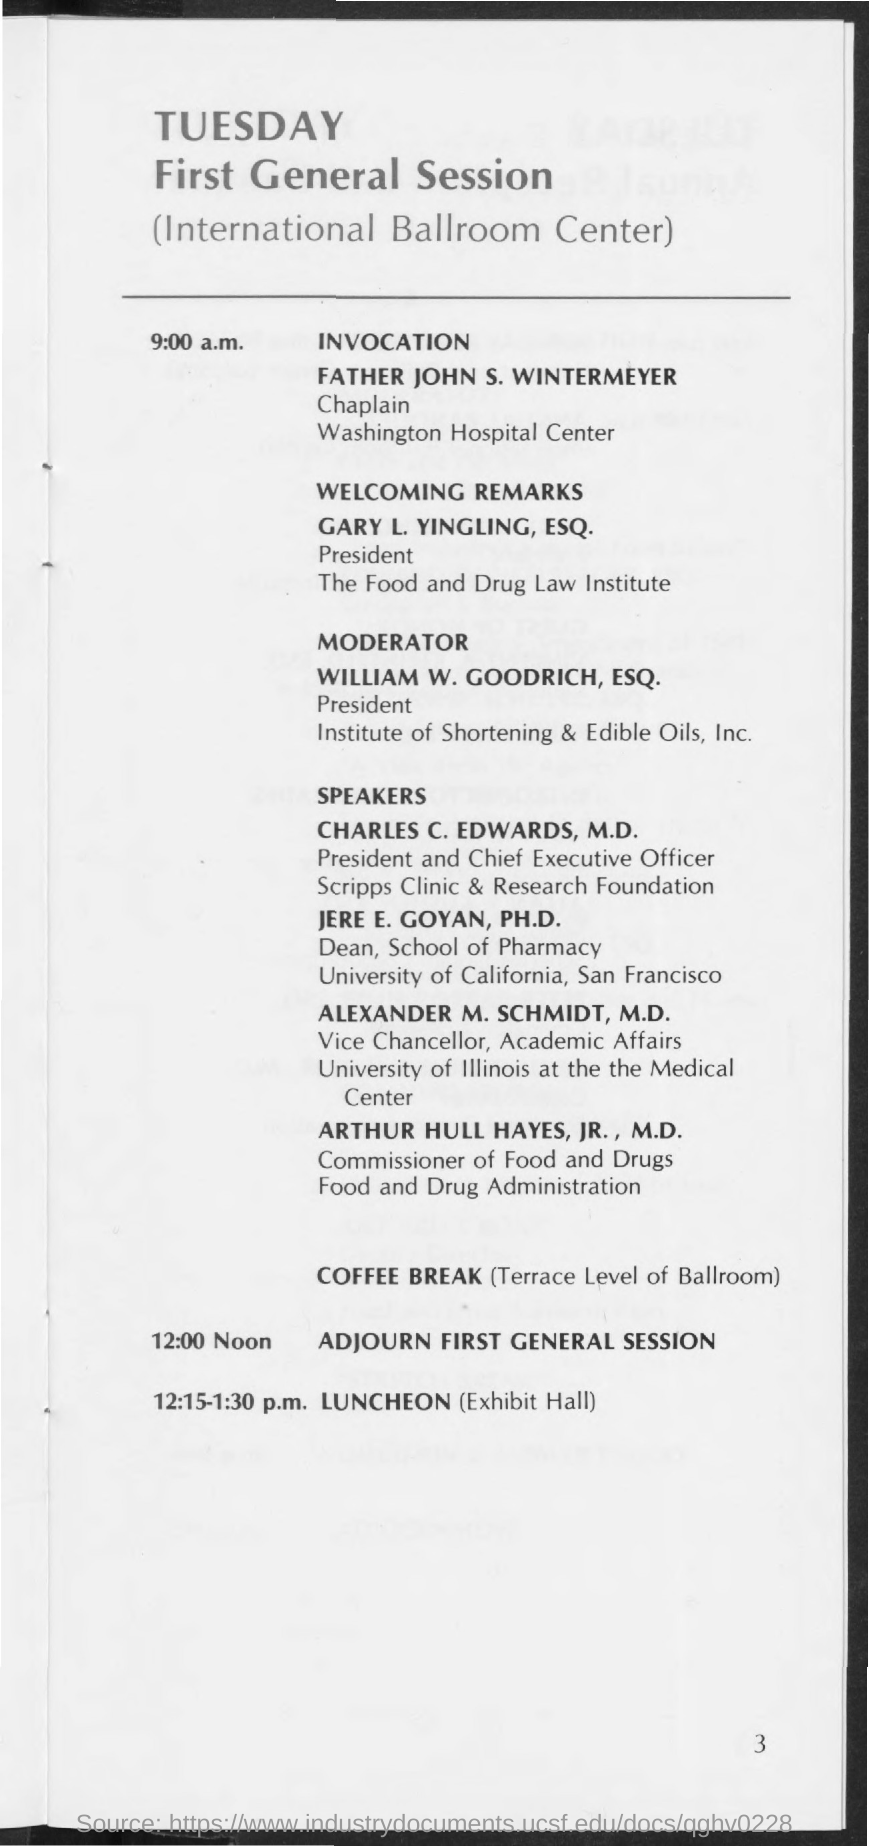Mention a couple of crucial points in this snapshot. The first general session is scheduled to be held on Tuesday. The president of Institute of Shortening and Edible Oils, Inc. is William W. Goodrich, ESQ. The chaplain of Washington Hospital Center is Father John S. Wintermeyer. The Commissioner of Food and Drugs of the Food and Drug Administration is Arthur Hull Hayes, Jr., M.D. The First General Session will be held at the International Ballroom Center. 